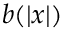<formula> <loc_0><loc_0><loc_500><loc_500>b ( \left | x \right | )</formula> 